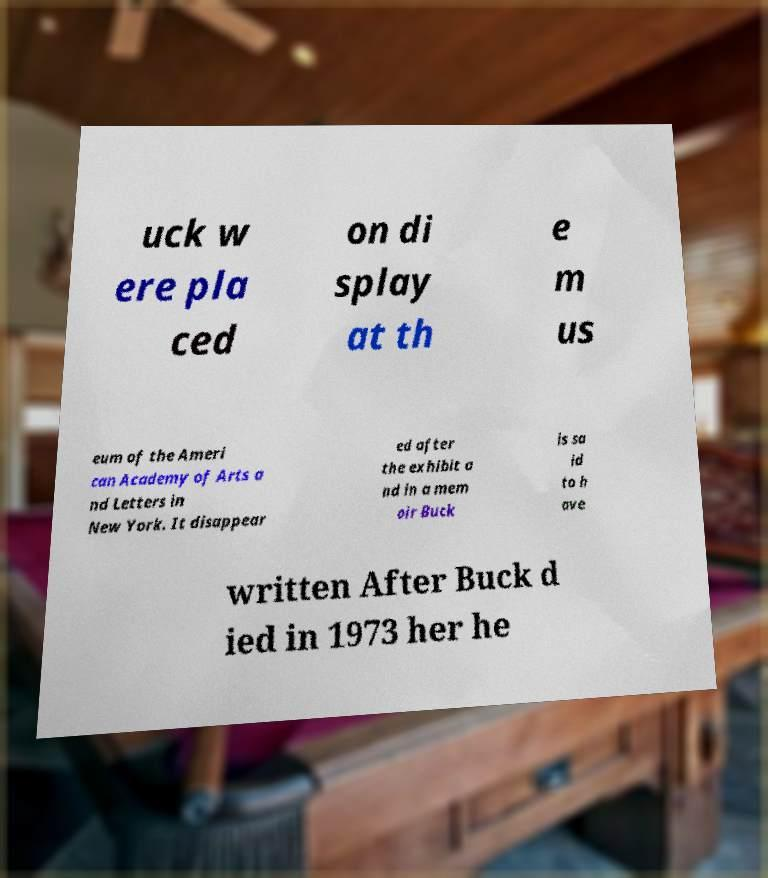What messages or text are displayed in this image? I need them in a readable, typed format. uck w ere pla ced on di splay at th e m us eum of the Ameri can Academy of Arts a nd Letters in New York. It disappear ed after the exhibit a nd in a mem oir Buck is sa id to h ave written After Buck d ied in 1973 her he 